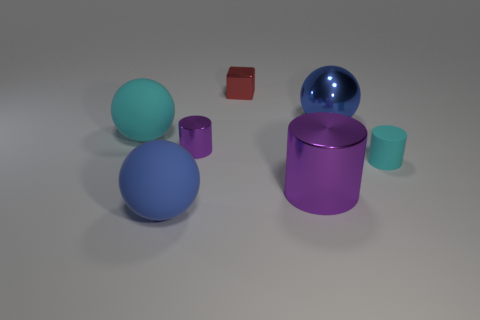There is a small cylinder on the right side of the big blue thing that is right of the big metallic object in front of the small cyan object; what is its material?
Your response must be concise. Rubber. How many large things are either red metallic objects or shiny things?
Your answer should be very brief. 2. What number of other objects are there of the same size as the metallic block?
Offer a terse response. 2. There is a cyan thing to the right of the large blue shiny ball; is it the same shape as the red shiny object?
Provide a short and direct response. No. The big metallic object that is the same shape as the tiny cyan object is what color?
Keep it short and to the point. Purple. Are there any other things that are the same shape as the large blue rubber object?
Ensure brevity in your answer.  Yes. Are there the same number of big things that are behind the large purple cylinder and large rubber balls?
Offer a very short reply. Yes. How many matte things are both to the left of the big blue matte ball and in front of the small purple thing?
Keep it short and to the point. 0. There is a blue matte object that is the same shape as the blue metal object; what size is it?
Provide a short and direct response. Large. How many big purple things have the same material as the tiny cyan thing?
Ensure brevity in your answer.  0. 